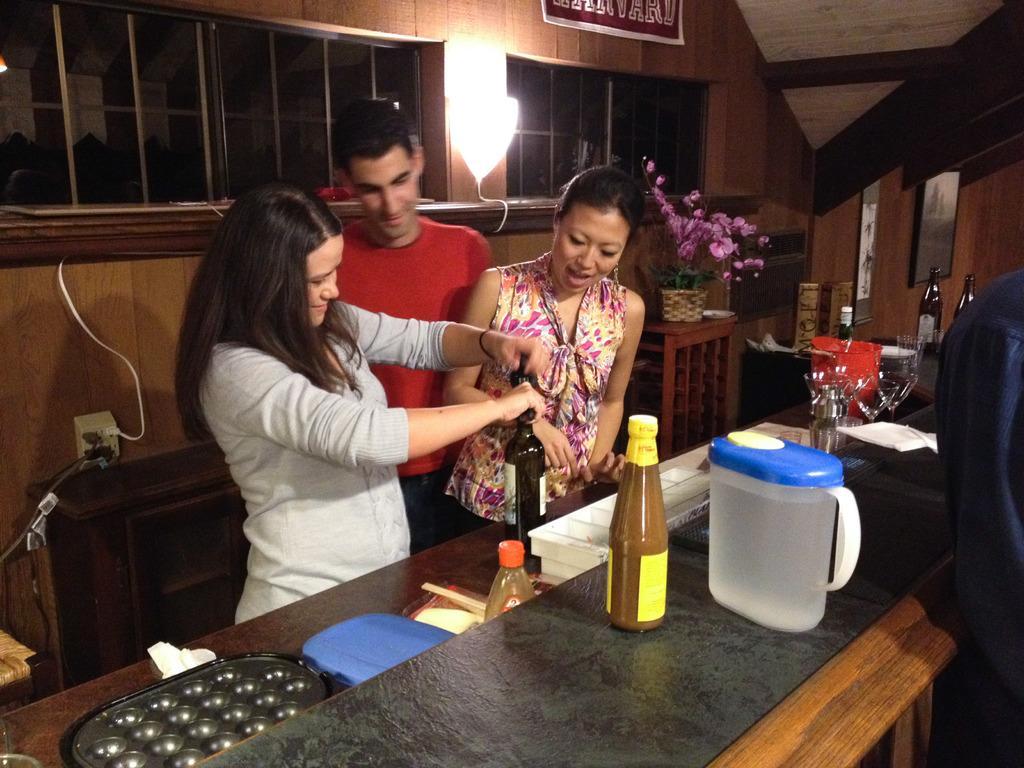In one or two sentences, can you explain what this image depicts? This picture is of inside the room. On the right we can see a table on the top of which a jug, boxes and bottles are placed. On the left there is a woman standing and opening the cap of a bottle and there is a man and a woman standing and we can see a house plant placed on the top of the table. In the background we can see a window, a wall lamp, picture frames hanging on the wall and a wall socket. 